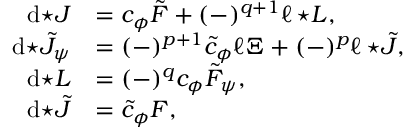<formula> <loc_0><loc_0><loc_500><loc_500>\begin{array} { r l } { d { ^ { * } J } } & { = c _ { \phi } \tilde { F } + ( - ) ^ { q + 1 } \ell \, { ^ { * } L } , } \\ { d { ^ { * } \tilde { J } _ { \psi } } } & { = ( - ) ^ { p + 1 } \tilde { c } _ { \phi } \ell \Xi + ( - ) ^ { p } \ell \, { ^ { * } \tilde { J } } , } \\ { d { ^ { * } L } } & { = ( - ) ^ { q } c _ { \phi } \tilde { F } _ { \psi } , } \\ { d { ^ { * } \tilde { J } } } & { = \tilde { c } _ { \phi } F , } \end{array}</formula> 